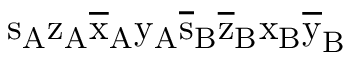Convert formula to latex. <formula><loc_0><loc_0><loc_500><loc_500>s _ { A } \mathrm { z _ { A } \mathrm { \overline { x } _ { A } \mathrm { y _ { A } \mathrm { \overline { s } _ { B } \mathrm { \overline { z } _ { B } \mathrm { x _ { B } \mathrm { \overline { y } _ { B } } } } } } } }</formula> 